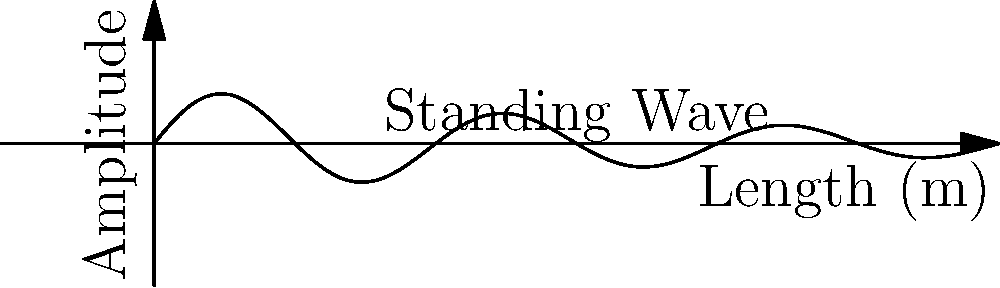As a production assistant working on a sound stage, you're tasked with optimizing the acoustics for a crucial scene. The studio space is rectangular, measuring 15 meters in length. If the speed of sound in the studio is 340 m/s, what is the fundamental resonance frequency of sound waves in this enclosed space? To solve this problem, we'll follow these steps:

1. Recall the formula for the fundamental frequency of a standing wave in an enclosed space:
   $$f = \frac{v}{2L}$$
   Where:
   $f$ = fundamental frequency (Hz)
   $v$ = speed of sound (m/s)
   $L$ = length of the space (m)

2. We're given:
   $v = 340$ m/s
   $L = 15$ m

3. Substitute these values into the equation:
   $$f = \frac{340}{2(15)}$$

4. Simplify:
   $$f = \frac{340}{30} = 11.33333...$$

5. Round to two decimal places for a practical answer in Hertz.
Answer: 11.33 Hz 